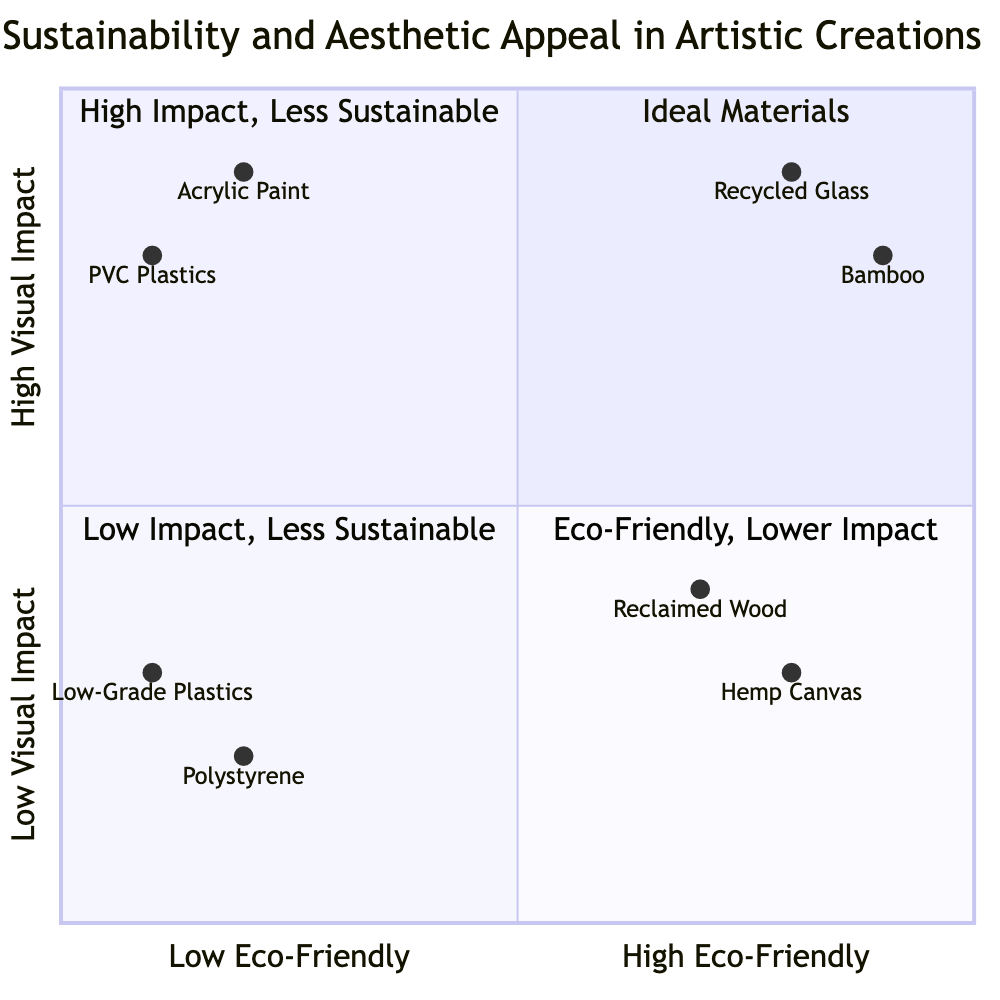What material has the highest visual impact? From the diagram, the materials with the highest visual impact are Recycled Glass and Acrylic Paint, both positioned near the top of the y-axis. However, Apostrophes are grouped together; Acrylic Paint has an associated high visual impact of 0.9, while Recycled Glass is slightly higher at 0.9 as well, indicating both are at the same visual impact level, but Recycled Glass is more eco-friendly
Answer: Recycled Glass How many materials are categorized as high eco-friendly and high visual impact? By examining the quadrant labeled "High Eco-Friendly - High Visual Impact," I can identify two materials: Recycled Glass and Bamboo, both of which fall into this category
Answer: 2 What is the visual impact of Hemp Canvas? In the quadrant labeled "High Eco-Friendly - Low Visual Impact," the value for Hemp Canvas is given as 0.3 on the y-axis, indicating its lower visual impact compared to others
Answer: 0.3 Which material has the lowest eco-friendliness? The quadrant "Low Eco-Friendly - Low Visual Impact" contains both Polystyrene and Low-Grade Plastics. Among them, Polystyrene has values of 0.2, indicating it is low in eco-friendliness
Answer: Polystyrene What is the overall trend as eco-friendliness increases? Observing the diagram from left to right, as the eco-friendly materials increase toward the right side of the x-axis, the visual impacts range drastically, especially in the "High Eco-Friendly - High Visual Impact" quadrant, which shows that some eco-friendly materials can still have high visual impacts
Answer: Diverse impacts What is the material associated with the "Eco-Friendly, Lower Impact" quadrant? This quadrant shows materials with high eco-friendliness but lower visual impact. From the data, the materials are Hemp Canvas and Reclaimed Wood, both providing eco-friendly solutions with less visual appeal
Answer: Hemp Canvas How does the visual impact of PVC Plastics compare to that of Acrylic Paint? Both materials are in the "Low Eco-Friendly - High Visual Impact" quadrant. The visual impact for PVC Plastics is 0.8, while Acrylic Paint has a visual impact of 0.9, which means Acrylic Paint has a slightly higher visual impact
Answer: Acrylic Paint What are the coordinates of Bamboo? In the "High Eco-Friendly - High Visual Impact" quadrant, Bamboo is represented with coordinates of [0.9, 0.8]. This means it has high eco-friendliness and relatively high visual impact compared to others
Answer: [0.9, 0.8] 